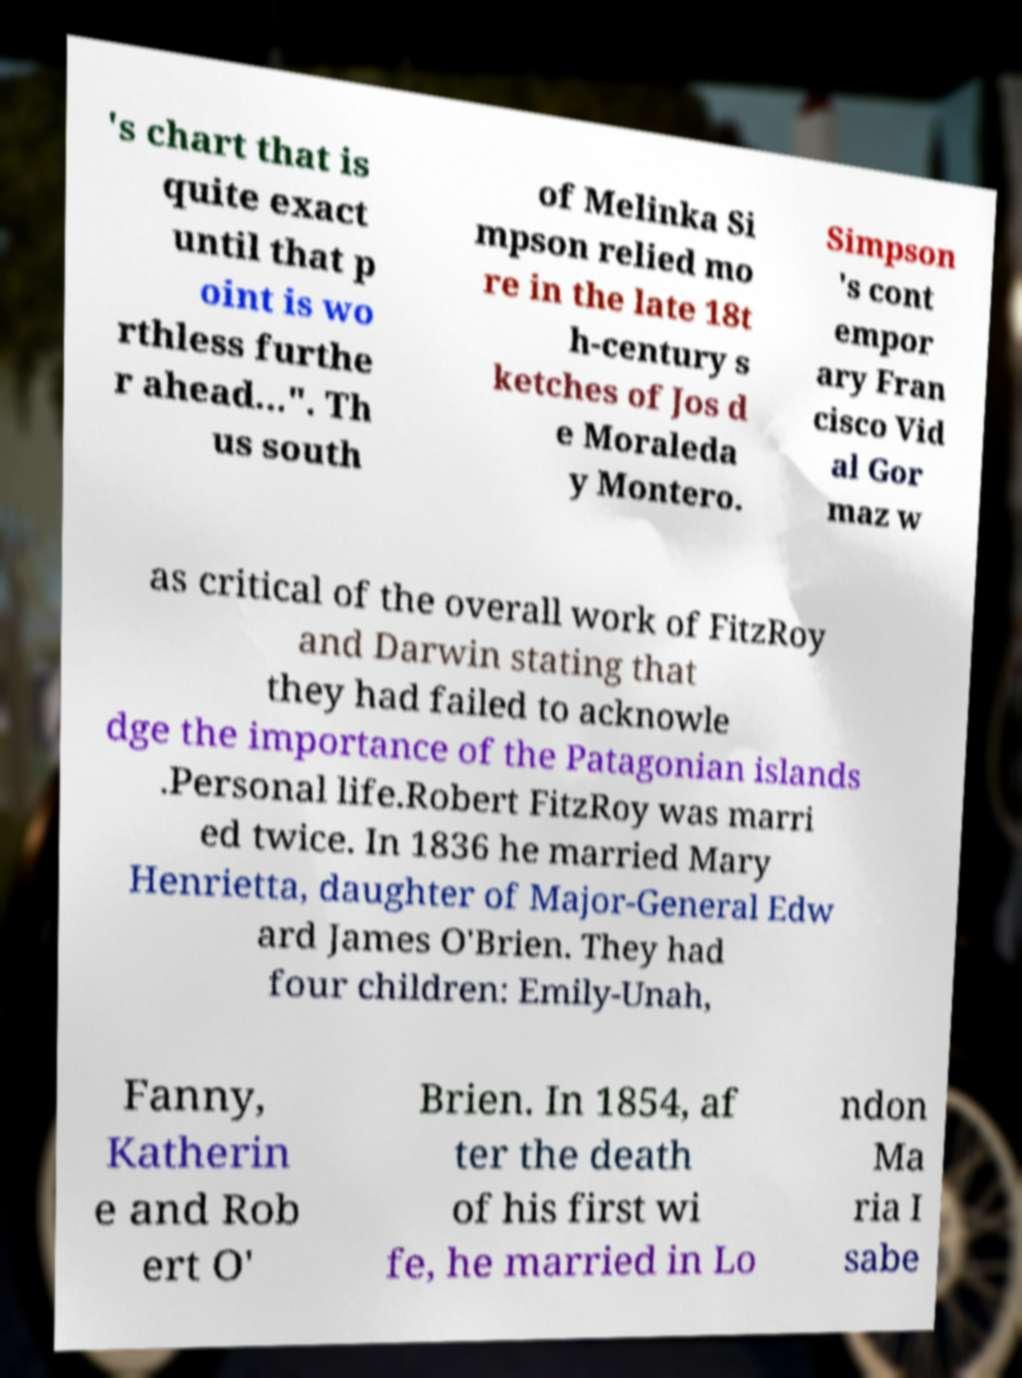There's text embedded in this image that I need extracted. Can you transcribe it verbatim? 's chart that is quite exact until that p oint is wo rthless furthe r ahead...". Th us south of Melinka Si mpson relied mo re in the late 18t h-century s ketches of Jos d e Moraleda y Montero. Simpson 's cont empor ary Fran cisco Vid al Gor maz w as critical of the overall work of FitzRoy and Darwin stating that they had failed to acknowle dge the importance of the Patagonian islands .Personal life.Robert FitzRoy was marri ed twice. In 1836 he married Mary Henrietta, daughter of Major-General Edw ard James O'Brien. They had four children: Emily-Unah, Fanny, Katherin e and Rob ert O' Brien. In 1854, af ter the death of his first wi fe, he married in Lo ndon Ma ria I sabe 